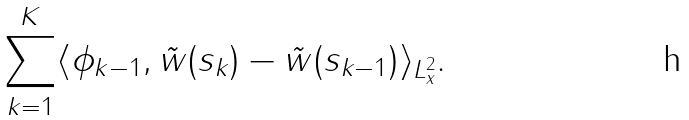<formula> <loc_0><loc_0><loc_500><loc_500>\sum _ { k = 1 } ^ { K } \langle \phi _ { k - 1 } , \tilde { w } ( s _ { k } ) - \tilde { w } ( s _ { k - 1 } ) \rangle _ { L ^ { 2 } _ { x } } .</formula> 